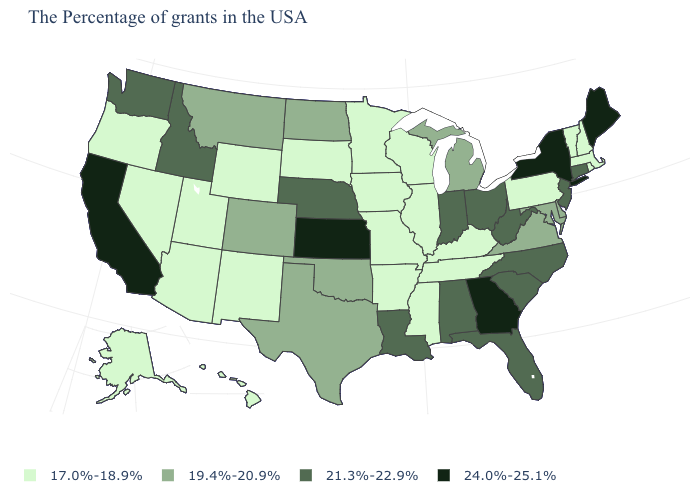What is the value of Rhode Island?
Keep it brief. 17.0%-18.9%. What is the value of West Virginia?
Short answer required. 21.3%-22.9%. Which states hav the highest value in the West?
Keep it brief. California. What is the value of Idaho?
Concise answer only. 21.3%-22.9%. Does Mississippi have the lowest value in the USA?
Give a very brief answer. Yes. Among the states that border Indiana , does Ohio have the lowest value?
Write a very short answer. No. What is the value of Vermont?
Concise answer only. 17.0%-18.9%. What is the value of Oregon?
Concise answer only. 17.0%-18.9%. What is the highest value in states that border Wisconsin?
Write a very short answer. 19.4%-20.9%. What is the value of Montana?
Write a very short answer. 19.4%-20.9%. Name the states that have a value in the range 21.3%-22.9%?
Quick response, please. Connecticut, New Jersey, North Carolina, South Carolina, West Virginia, Ohio, Florida, Indiana, Alabama, Louisiana, Nebraska, Idaho, Washington. Name the states that have a value in the range 19.4%-20.9%?
Quick response, please. Delaware, Maryland, Virginia, Michigan, Oklahoma, Texas, North Dakota, Colorado, Montana. What is the value of Utah?
Short answer required. 17.0%-18.9%. Which states have the highest value in the USA?
Write a very short answer. Maine, New York, Georgia, Kansas, California. What is the highest value in the USA?
Answer briefly. 24.0%-25.1%. 